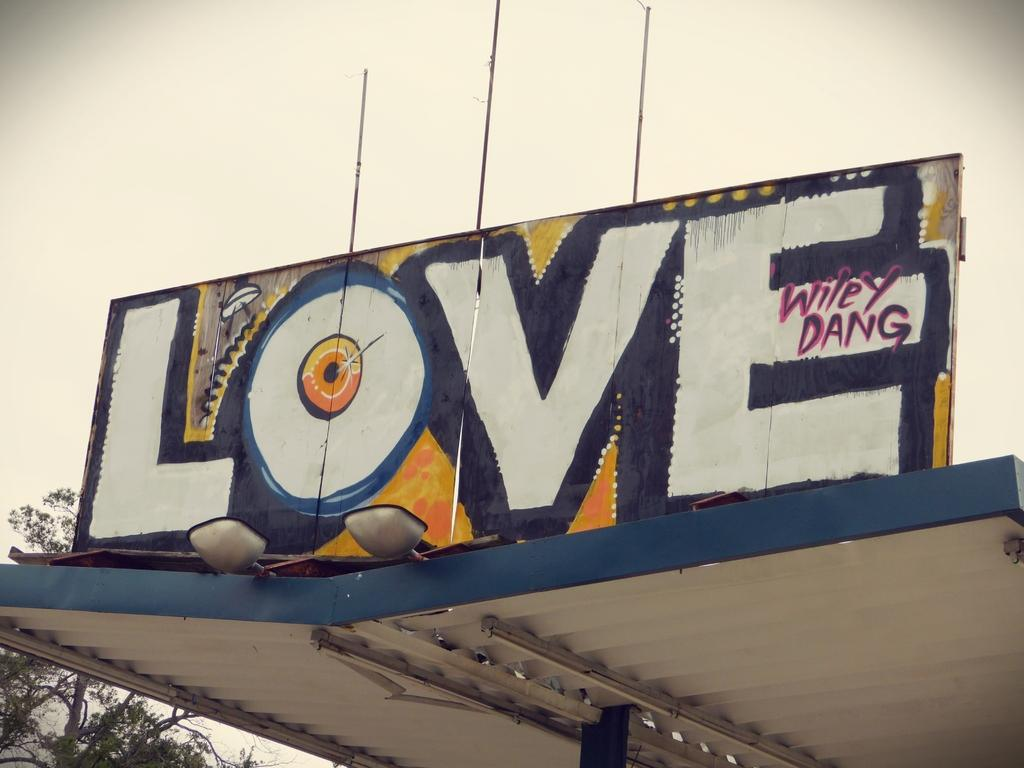<image>
Describe the image concisely. A graffiti sign has the word LOVE painted on it. 